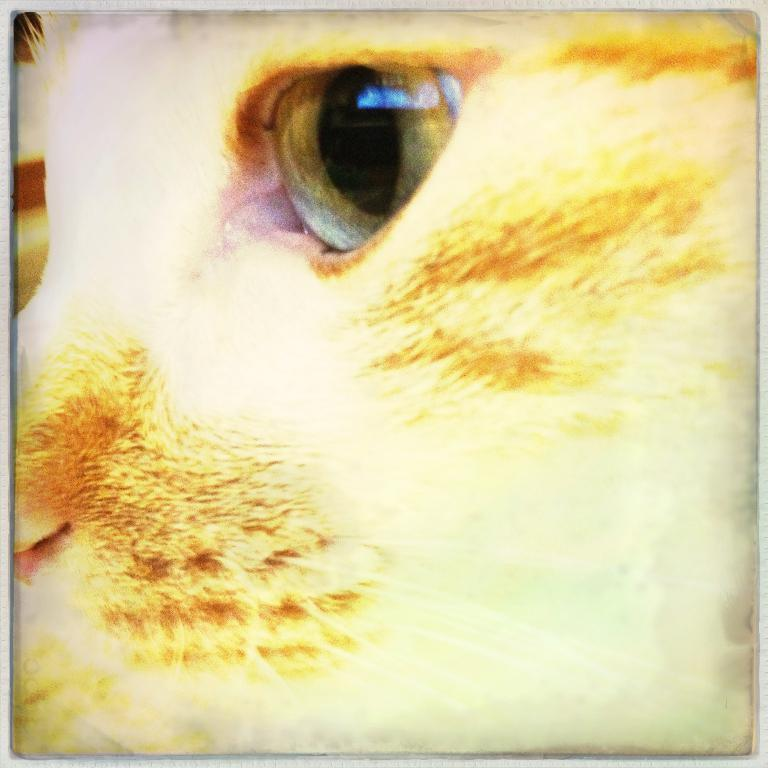What is the main subject in the foreground of the image? There is an animal in the foreground of the image. What type of nerve is responsible for the animal's ability to perform division in the image? There is no mention of nerves or division in the image, as it only features an animal in the foreground. 